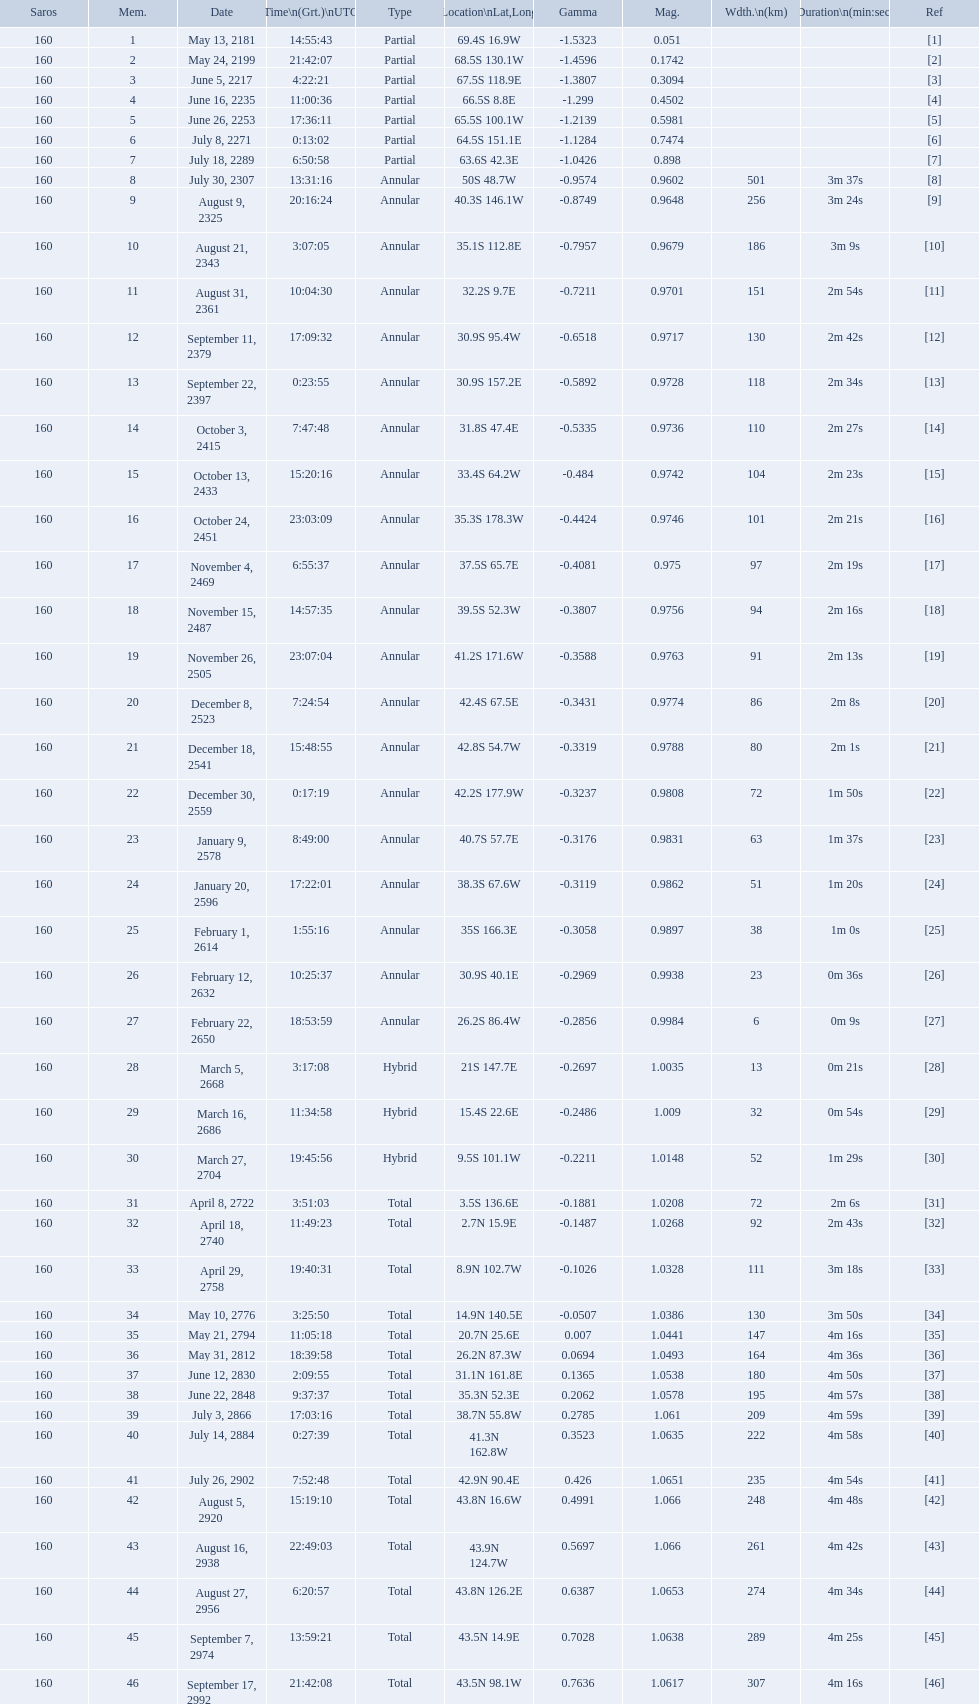How many solar saros events lasted longer than 4 minutes? 12. 